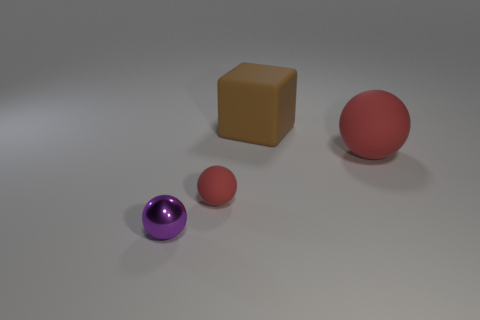Subtract all rubber balls. How many balls are left? 1 Add 3 matte cylinders. How many objects exist? 7 Subtract all spheres. How many objects are left? 1 Subtract 0 green blocks. How many objects are left? 4 Subtract all red cylinders. Subtract all large matte things. How many objects are left? 2 Add 3 red balls. How many red balls are left? 5 Add 1 green metal objects. How many green metal objects exist? 1 